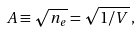<formula> <loc_0><loc_0><loc_500><loc_500>A \equiv \sqrt { n _ { e } } = \sqrt { 1 / V } \, ,</formula> 